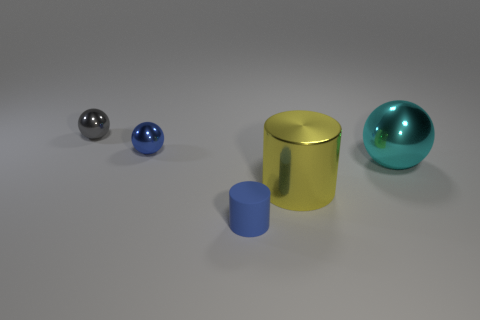Subtract all tiny metal spheres. How many spheres are left? 1 Add 2 big balls. How many objects exist? 7 Subtract all cyan balls. How many balls are left? 2 Subtract 0 purple cylinders. How many objects are left? 5 Subtract all cylinders. How many objects are left? 3 Subtract 1 balls. How many balls are left? 2 Subtract all red spheres. Subtract all green cylinders. How many spheres are left? 3 Subtract all large gray objects. Subtract all cylinders. How many objects are left? 3 Add 3 metallic cylinders. How many metallic cylinders are left? 4 Add 3 metallic spheres. How many metallic spheres exist? 6 